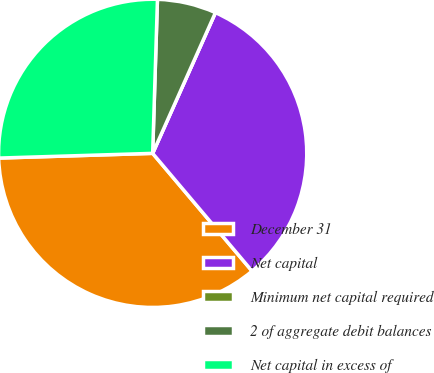Convert chart. <chart><loc_0><loc_0><loc_500><loc_500><pie_chart><fcel>December 31<fcel>Net capital<fcel>Minimum net capital required<fcel>2 of aggregate debit balances<fcel>Net capital in excess of<nl><fcel>35.67%<fcel>32.16%<fcel>0.0%<fcel>6.18%<fcel>25.98%<nl></chart> 